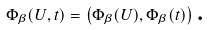<formula> <loc_0><loc_0><loc_500><loc_500>\Phi _ { \beta } ( U , t ) = \left ( \Phi _ { \beta } ( U ) , \Phi _ { \beta } ( t ) \right ) \text {.}</formula> 